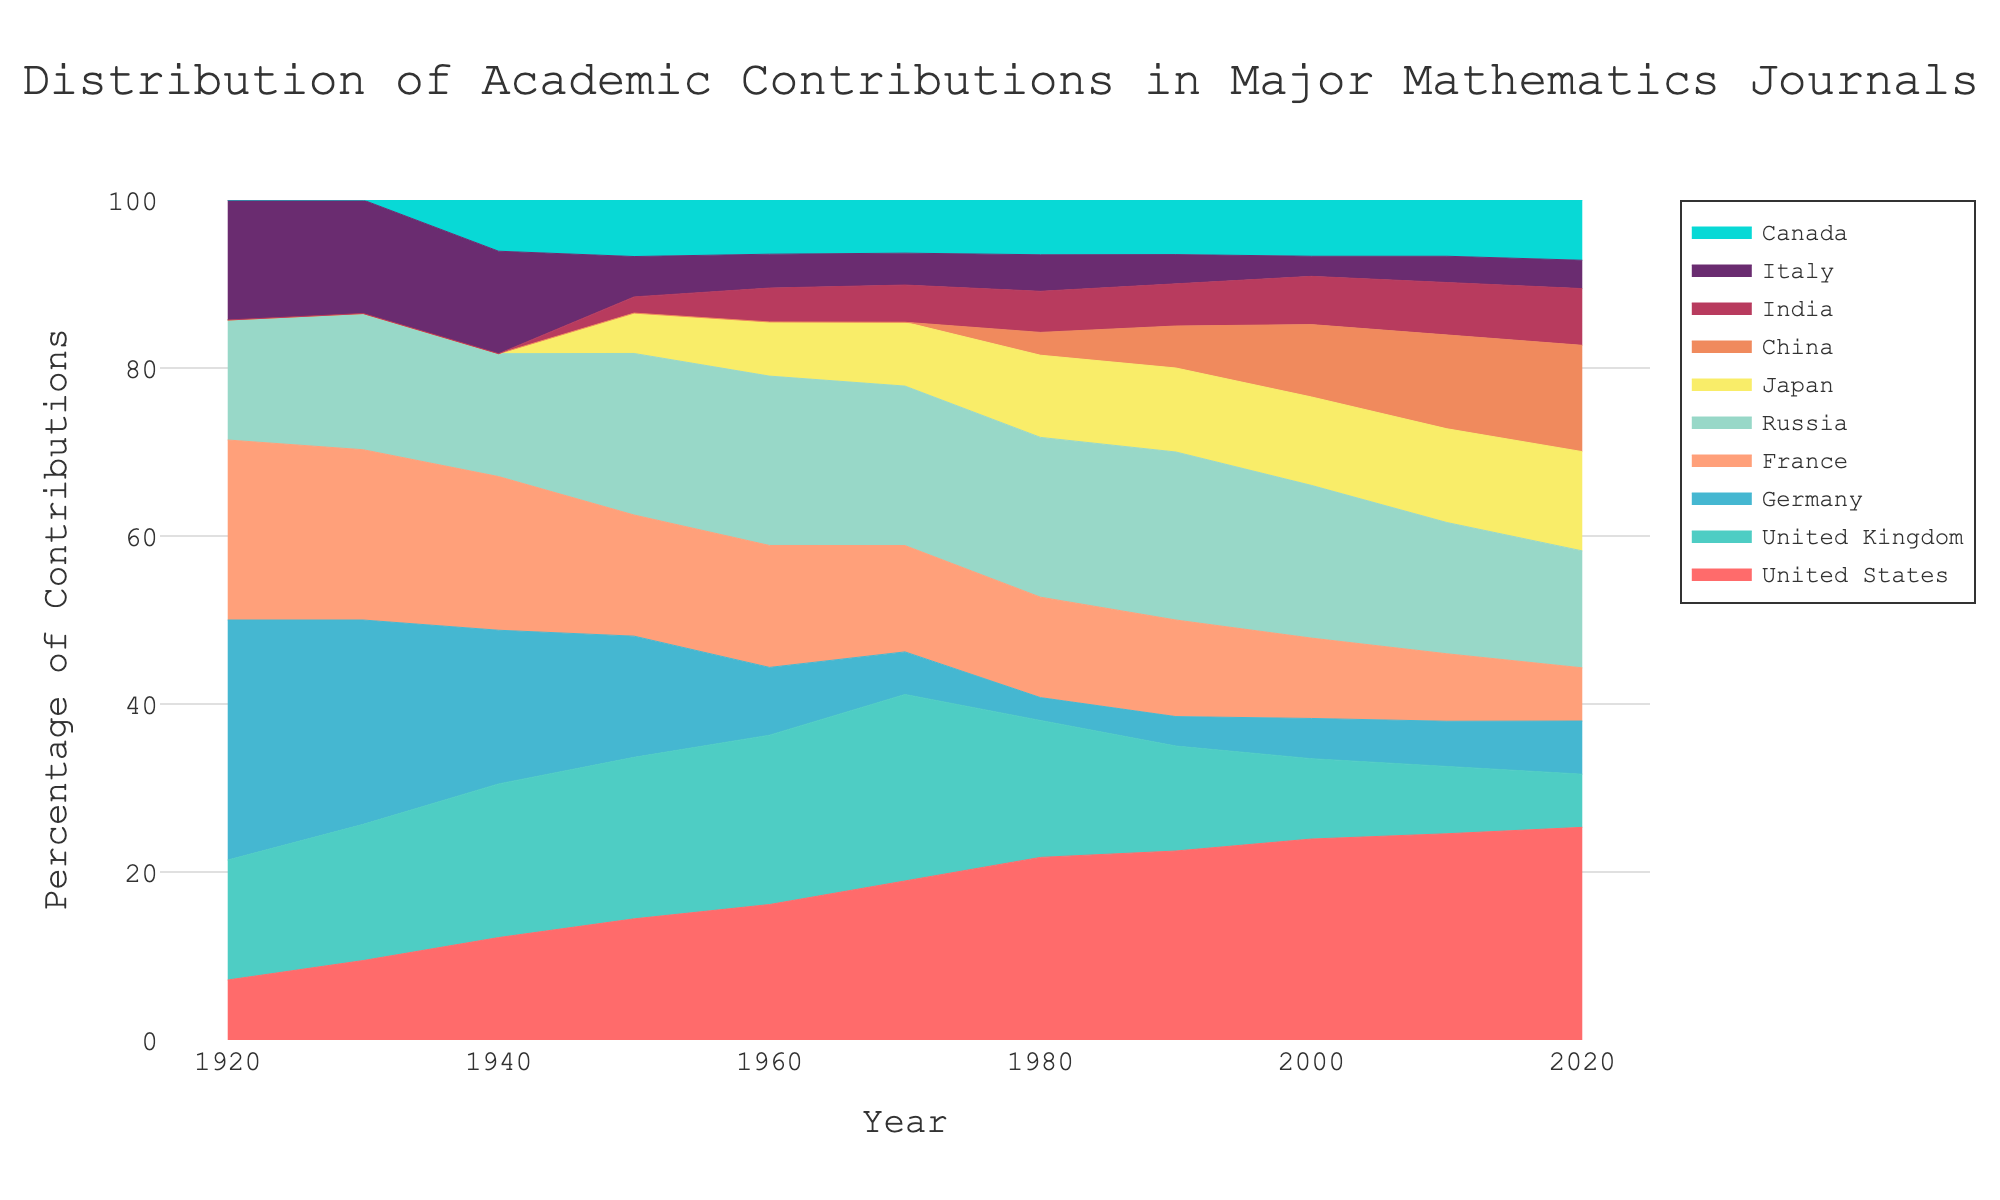What is the title of the chart? The title is usually placed at the top of the chart and in this case, it is a descriptive phrase that outlines the purpose of the chart. You can directly read the title.
Answer: Distribution of Academic Contributions in Major Mathematics Journals How does the contribution from the United States change from 1920 to 2020? Track the United States' data points along the X-axis from the year 1920 to 2020. It starts at 5% in 1920 and ends at 60% in 2020.
Answer: Increases Which country shows a decrease in contributions after its peak, and what is the peak contribution? Identify the peak contribution for countries. The UK peaks at around 35% in 1970 and then decreases.
Answer: United Kingdom, 35% In which decades do Germany and Japan have equivalent contributions? Look at the overlapping areas of Germany and Japan. Around the 2000s (or late 90s), Germany and Japan have similar contributions.
Answer: 2000 What is the combined percentage contribution of Russia and China in 2020? Add up the contributions from the respective countries for the year 2020. Russia contributes 33%, and China contributes 30%.
Answer: 63% Which country has the steepest increase in contributions over the given century? Compare the slopes of the contributions' lines from the beginning to the end. China shows a steep increase especially from 1980 onwards.
Answer: China How did the contribution of France evolve throughout the century? Track the percentage for France across the years. It starts at 15%, peaks around the 1980-1990 period with a slight increase, and ends at 15% in 2020.
Answer: Minor fluctuations, ends similar to start Which country had no contribution until after 1950 and what is its maximum contribution? Look at the countries whose contribution starts from zero initially. China starts contributing after 1950 and peaks at 30% in 2020.
Answer: China, 30% By how much did the contribution of India increase from 1950 to 2020? Subtract the contribution percentage of India in 1950 from that in 2020. It starts at 2% in 1950 and rises to 16% by 2020.
Answer: 14% Which countries show a stable or nearly stable contribution throughout the century? Observe the countries with relatively flat lines or minor fluctuations. France and Italy have relatively stable contributions over the century.
Answer: France, Italy 